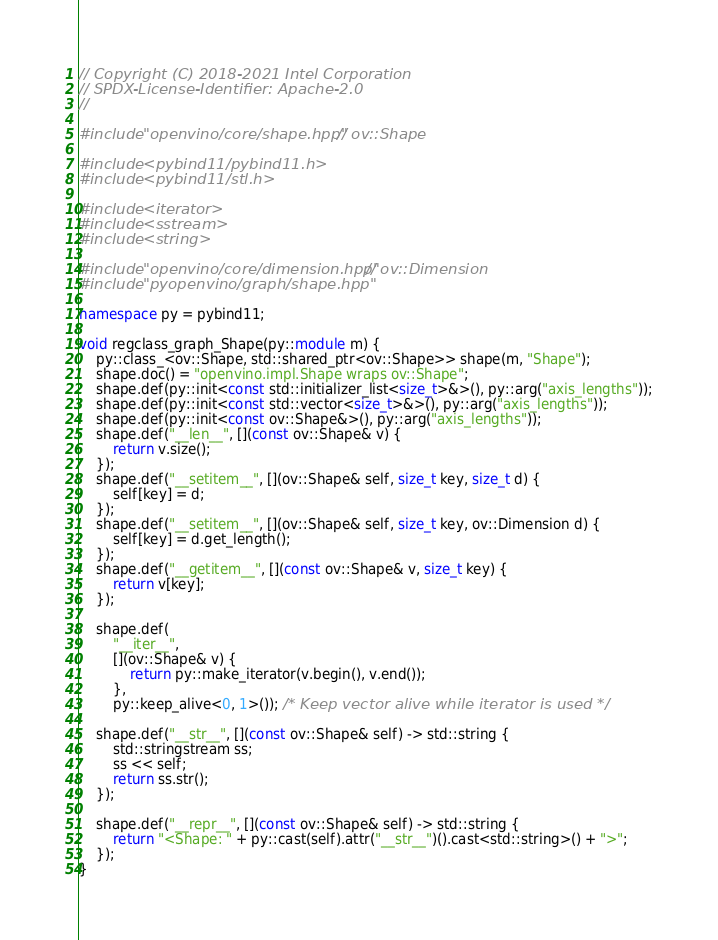<code> <loc_0><loc_0><loc_500><loc_500><_C++_>// Copyright (C) 2018-2021 Intel Corporation
// SPDX-License-Identifier: Apache-2.0
//

#include "openvino/core/shape.hpp"  // ov::Shape

#include <pybind11/pybind11.h>
#include <pybind11/stl.h>

#include <iterator>
#include <sstream>
#include <string>

#include "openvino/core/dimension.hpp"  // ov::Dimension
#include "pyopenvino/graph/shape.hpp"

namespace py = pybind11;

void regclass_graph_Shape(py::module m) {
    py::class_<ov::Shape, std::shared_ptr<ov::Shape>> shape(m, "Shape");
    shape.doc() = "openvino.impl.Shape wraps ov::Shape";
    shape.def(py::init<const std::initializer_list<size_t>&>(), py::arg("axis_lengths"));
    shape.def(py::init<const std::vector<size_t>&>(), py::arg("axis_lengths"));
    shape.def(py::init<const ov::Shape&>(), py::arg("axis_lengths"));
    shape.def("__len__", [](const ov::Shape& v) {
        return v.size();
    });
    shape.def("__setitem__", [](ov::Shape& self, size_t key, size_t d) {
        self[key] = d;
    });
    shape.def("__setitem__", [](ov::Shape& self, size_t key, ov::Dimension d) {
        self[key] = d.get_length();
    });
    shape.def("__getitem__", [](const ov::Shape& v, size_t key) {
        return v[key];
    });

    shape.def(
        "__iter__",
        [](ov::Shape& v) {
            return py::make_iterator(v.begin(), v.end());
        },
        py::keep_alive<0, 1>()); /* Keep vector alive while iterator is used */

    shape.def("__str__", [](const ov::Shape& self) -> std::string {
        std::stringstream ss;
        ss << self;
        return ss.str();
    });

    shape.def("__repr__", [](const ov::Shape& self) -> std::string {
        return "<Shape: " + py::cast(self).attr("__str__")().cast<std::string>() + ">";
    });
}
</code> 